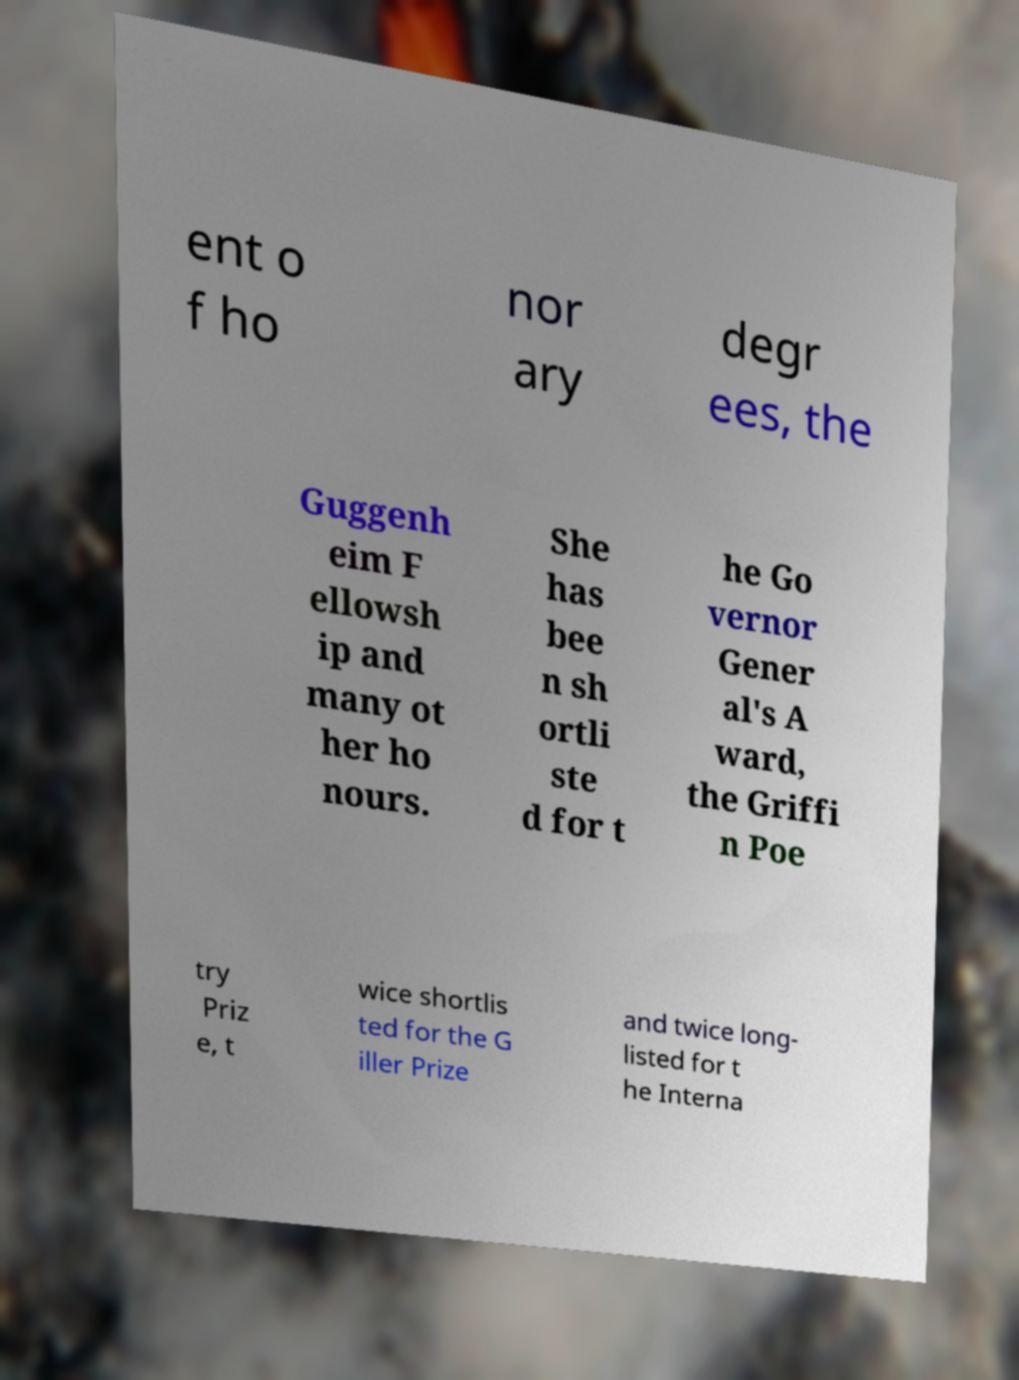Can you read and provide the text displayed in the image?This photo seems to have some interesting text. Can you extract and type it out for me? ent o f ho nor ary degr ees, the Guggenh eim F ellowsh ip and many ot her ho nours. She has bee n sh ortli ste d for t he Go vernor Gener al's A ward, the Griffi n Poe try Priz e, t wice shortlis ted for the G iller Prize and twice long- listed for t he Interna 